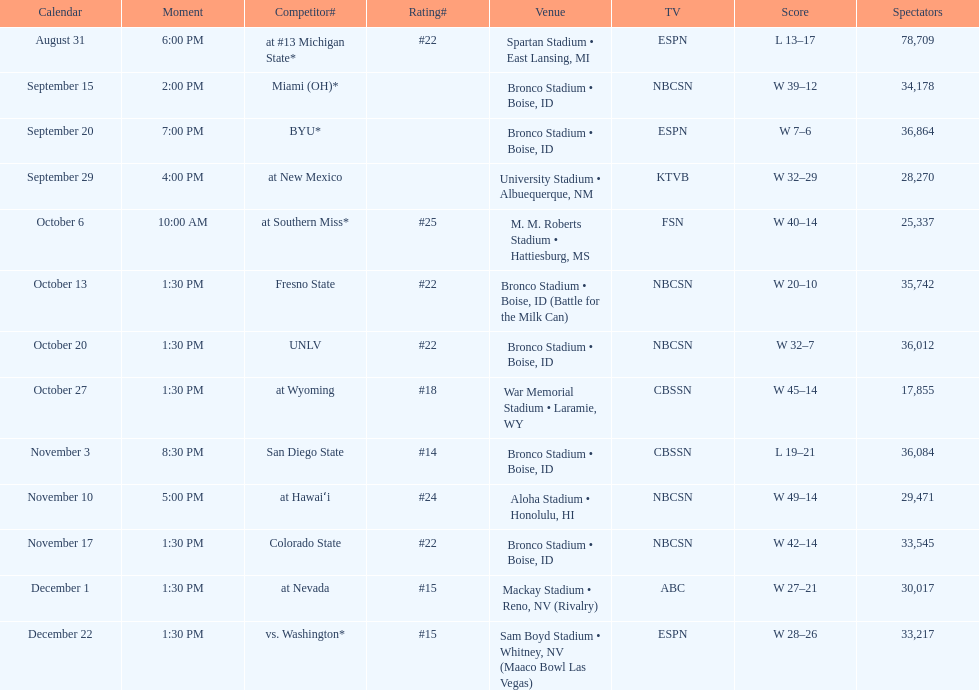Which team has the highest rank among those listed? San Diego State. 